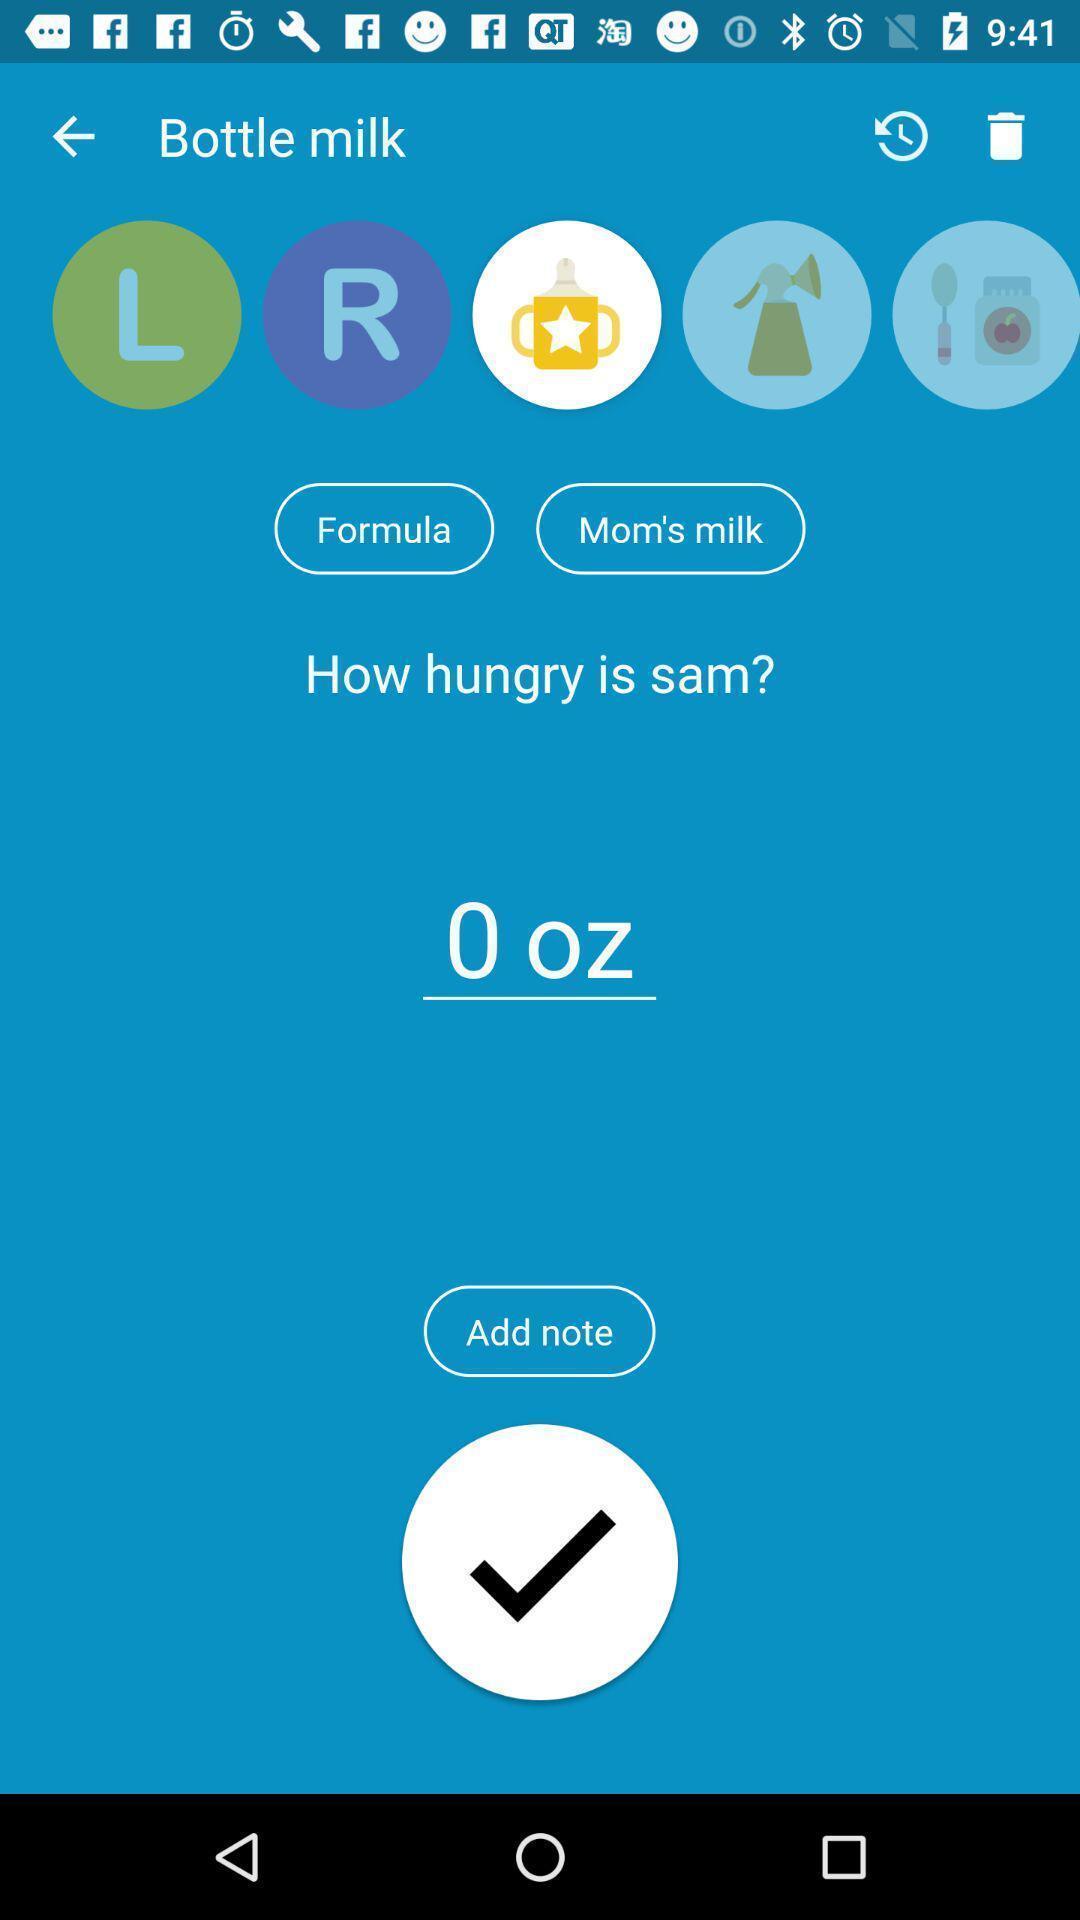Tell me what you see in this picture. Screen displaying the page of a medical app. 